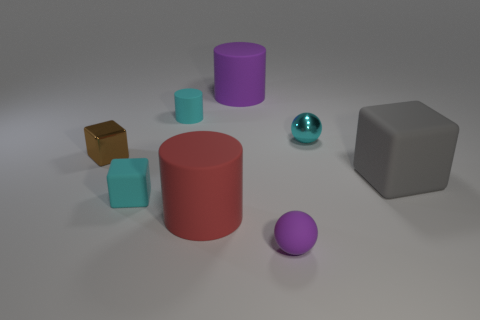Add 1 large purple balls. How many objects exist? 9 Subtract all spheres. How many objects are left? 6 Subtract all large green rubber spheres. Subtract all gray objects. How many objects are left? 7 Add 1 cylinders. How many cylinders are left? 4 Add 5 purple blocks. How many purple blocks exist? 5 Subtract 0 brown cylinders. How many objects are left? 8 